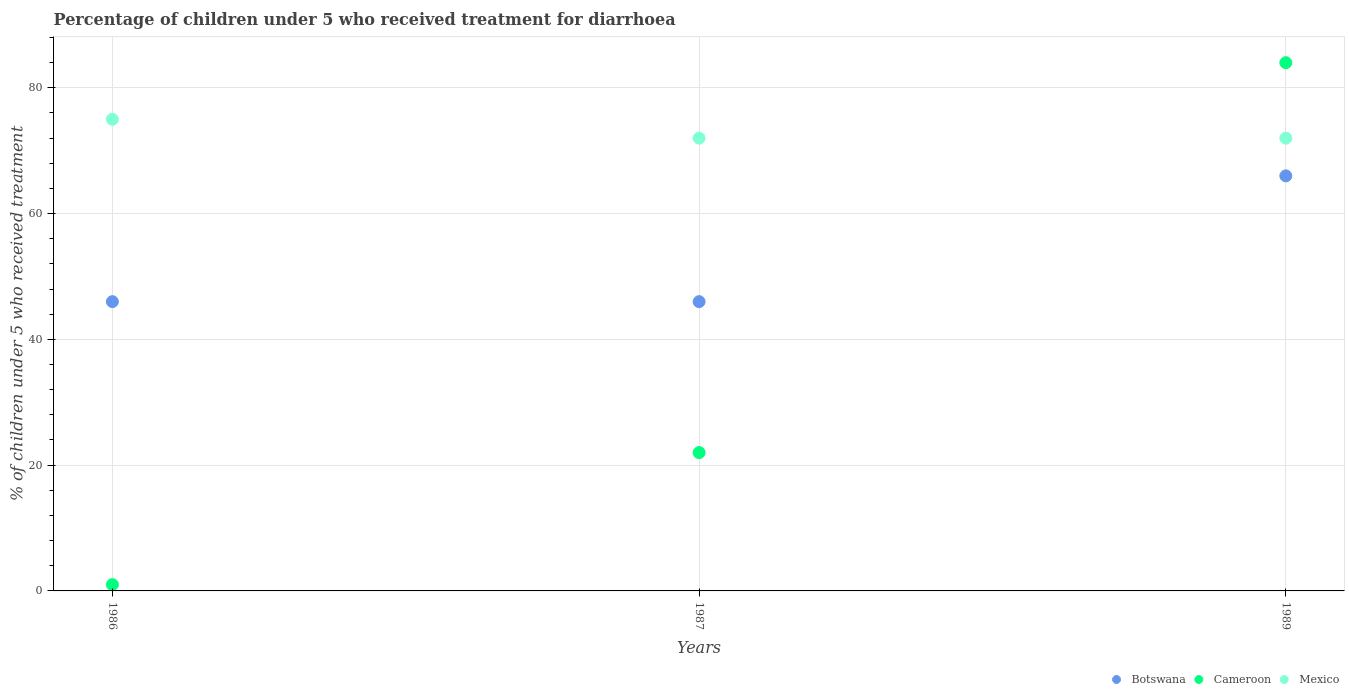What is the percentage of children who received treatment for diarrhoea  in Mexico in 1989?
Make the answer very short. 72. In which year was the percentage of children who received treatment for diarrhoea  in Botswana maximum?
Give a very brief answer. 1989. What is the total percentage of children who received treatment for diarrhoea  in Cameroon in the graph?
Give a very brief answer. 107. What is the difference between the percentage of children who received treatment for diarrhoea  in Botswana in 1987 and that in 1989?
Your answer should be very brief. -20. What is the difference between the percentage of children who received treatment for diarrhoea  in Mexico in 1986 and the percentage of children who received treatment for diarrhoea  in Cameroon in 1987?
Provide a succinct answer. 53. What is the average percentage of children who received treatment for diarrhoea  in Cameroon per year?
Provide a succinct answer. 35.67. In the year 1986, what is the difference between the percentage of children who received treatment for diarrhoea  in Cameroon and percentage of children who received treatment for diarrhoea  in Botswana?
Offer a very short reply. -45. What is the ratio of the percentage of children who received treatment for diarrhoea  in Mexico in 1987 to that in 1989?
Make the answer very short. 1. Is the percentage of children who received treatment for diarrhoea  in Cameroon in 1986 less than that in 1989?
Provide a short and direct response. Yes. What is the difference between the highest and the second highest percentage of children who received treatment for diarrhoea  in Mexico?
Your response must be concise. 3. What is the difference between the highest and the lowest percentage of children who received treatment for diarrhoea  in Mexico?
Your response must be concise. 3. In how many years, is the percentage of children who received treatment for diarrhoea  in Mexico greater than the average percentage of children who received treatment for diarrhoea  in Mexico taken over all years?
Your answer should be very brief. 1. What is the difference between two consecutive major ticks on the Y-axis?
Ensure brevity in your answer.  20. Are the values on the major ticks of Y-axis written in scientific E-notation?
Offer a very short reply. No. Does the graph contain any zero values?
Offer a terse response. No. Does the graph contain grids?
Provide a succinct answer. Yes. Where does the legend appear in the graph?
Your answer should be compact. Bottom right. What is the title of the graph?
Provide a short and direct response. Percentage of children under 5 who received treatment for diarrhoea. Does "China" appear as one of the legend labels in the graph?
Your response must be concise. No. What is the label or title of the X-axis?
Offer a terse response. Years. What is the label or title of the Y-axis?
Make the answer very short. % of children under 5 who received treatment. What is the % of children under 5 who received treatment of Mexico in 1986?
Offer a very short reply. 75. What is the % of children under 5 who received treatment in Botswana in 1987?
Your answer should be compact. 46. Across all years, what is the maximum % of children under 5 who received treatment in Botswana?
Offer a very short reply. 66. Across all years, what is the maximum % of children under 5 who received treatment in Mexico?
Your response must be concise. 75. Across all years, what is the minimum % of children under 5 who received treatment in Botswana?
Ensure brevity in your answer.  46. What is the total % of children under 5 who received treatment of Botswana in the graph?
Keep it short and to the point. 158. What is the total % of children under 5 who received treatment of Cameroon in the graph?
Offer a very short reply. 107. What is the total % of children under 5 who received treatment in Mexico in the graph?
Your answer should be compact. 219. What is the difference between the % of children under 5 who received treatment in Mexico in 1986 and that in 1987?
Offer a very short reply. 3. What is the difference between the % of children under 5 who received treatment of Cameroon in 1986 and that in 1989?
Your answer should be very brief. -83. What is the difference between the % of children under 5 who received treatment of Cameroon in 1987 and that in 1989?
Ensure brevity in your answer.  -62. What is the difference between the % of children under 5 who received treatment of Mexico in 1987 and that in 1989?
Give a very brief answer. 0. What is the difference between the % of children under 5 who received treatment of Botswana in 1986 and the % of children under 5 who received treatment of Mexico in 1987?
Provide a short and direct response. -26. What is the difference between the % of children under 5 who received treatment in Cameroon in 1986 and the % of children under 5 who received treatment in Mexico in 1987?
Your response must be concise. -71. What is the difference between the % of children under 5 who received treatment in Botswana in 1986 and the % of children under 5 who received treatment in Cameroon in 1989?
Your answer should be very brief. -38. What is the difference between the % of children under 5 who received treatment in Cameroon in 1986 and the % of children under 5 who received treatment in Mexico in 1989?
Make the answer very short. -71. What is the difference between the % of children under 5 who received treatment of Botswana in 1987 and the % of children under 5 who received treatment of Cameroon in 1989?
Your answer should be compact. -38. What is the difference between the % of children under 5 who received treatment of Botswana in 1987 and the % of children under 5 who received treatment of Mexico in 1989?
Offer a terse response. -26. What is the average % of children under 5 who received treatment of Botswana per year?
Your response must be concise. 52.67. What is the average % of children under 5 who received treatment in Cameroon per year?
Ensure brevity in your answer.  35.67. In the year 1986, what is the difference between the % of children under 5 who received treatment in Cameroon and % of children under 5 who received treatment in Mexico?
Your response must be concise. -74. In the year 1989, what is the difference between the % of children under 5 who received treatment of Botswana and % of children under 5 who received treatment of Cameroon?
Ensure brevity in your answer.  -18. What is the ratio of the % of children under 5 who received treatment in Cameroon in 1986 to that in 1987?
Provide a succinct answer. 0.05. What is the ratio of the % of children under 5 who received treatment of Mexico in 1986 to that in 1987?
Provide a succinct answer. 1.04. What is the ratio of the % of children under 5 who received treatment in Botswana in 1986 to that in 1989?
Your answer should be compact. 0.7. What is the ratio of the % of children under 5 who received treatment in Cameroon in 1986 to that in 1989?
Offer a terse response. 0.01. What is the ratio of the % of children under 5 who received treatment in Mexico in 1986 to that in 1989?
Provide a short and direct response. 1.04. What is the ratio of the % of children under 5 who received treatment in Botswana in 1987 to that in 1989?
Keep it short and to the point. 0.7. What is the ratio of the % of children under 5 who received treatment in Cameroon in 1987 to that in 1989?
Offer a terse response. 0.26. What is the difference between the highest and the second highest % of children under 5 who received treatment of Cameroon?
Make the answer very short. 62. What is the difference between the highest and the second highest % of children under 5 who received treatment in Mexico?
Keep it short and to the point. 3. What is the difference between the highest and the lowest % of children under 5 who received treatment of Botswana?
Offer a terse response. 20. What is the difference between the highest and the lowest % of children under 5 who received treatment in Mexico?
Your answer should be very brief. 3. 